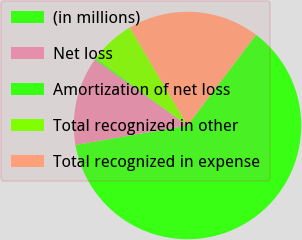Convert chart to OTSL. <chart><loc_0><loc_0><loc_500><loc_500><pie_chart><fcel>(in millions)<fcel>Net loss<fcel>Amortization of net loss<fcel>Total recognized in other<fcel>Total recognized in expense<nl><fcel>61.98%<fcel>12.59%<fcel>0.25%<fcel>6.42%<fcel>18.77%<nl></chart> 